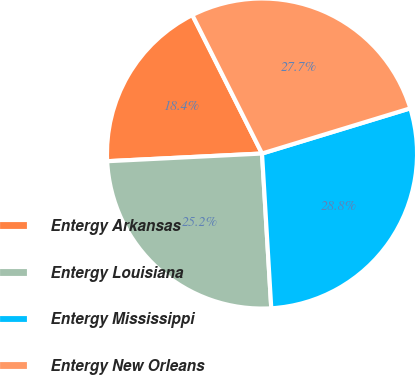Convert chart to OTSL. <chart><loc_0><loc_0><loc_500><loc_500><pie_chart><fcel>Entergy Arkansas<fcel>Entergy Louisiana<fcel>Entergy Mississippi<fcel>Entergy New Orleans<nl><fcel>18.37%<fcel>25.16%<fcel>28.76%<fcel>27.71%<nl></chart> 